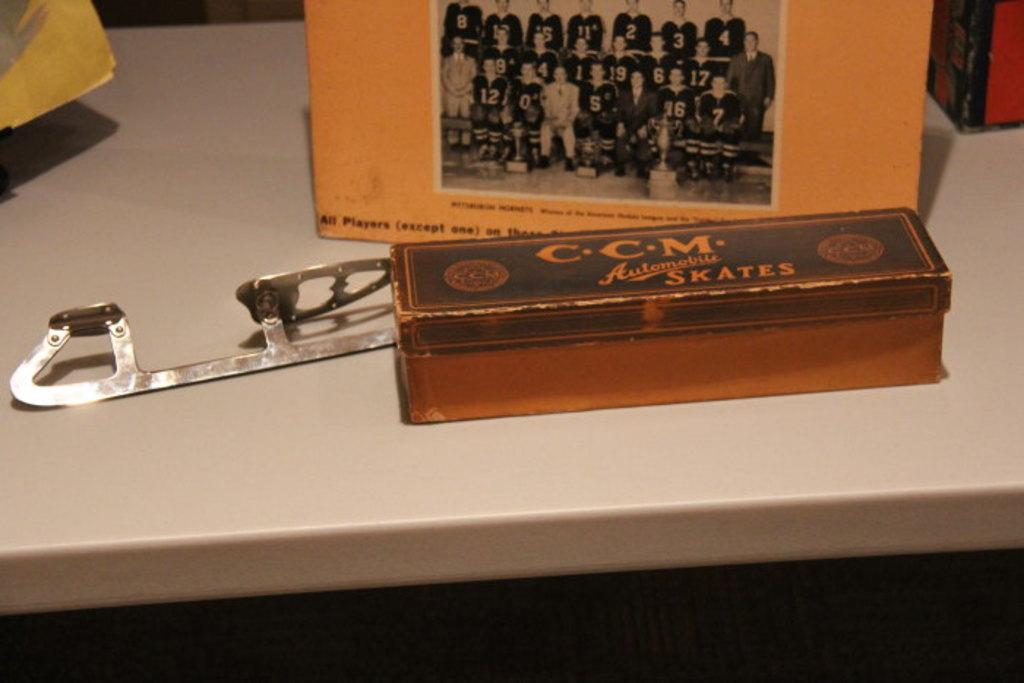<image>
Render a clear and concise summary of the photo. A metal box serves as the packaging for CCM Automatic Skates. 